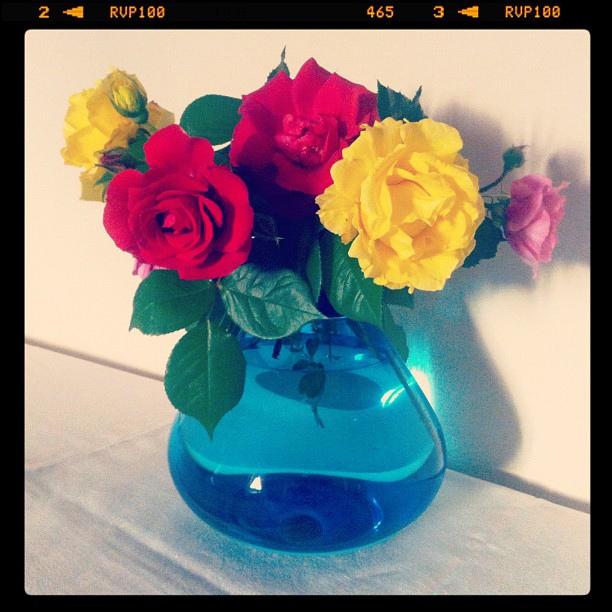What kind of flowers are these?
Short answer required. Roses. What kind of flower is the red one?
Write a very short answer. Rose. What color is the vase?
Quick response, please. Blue. Is the vase on the floor?
Keep it brief. Yes. 